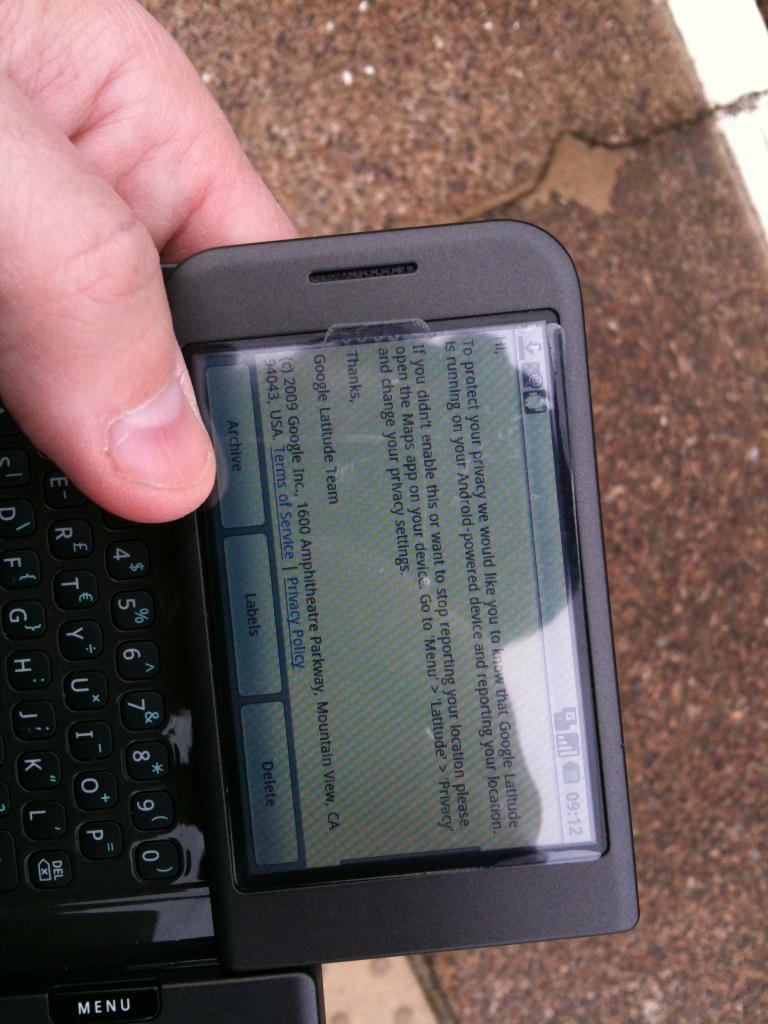<image>
Relay a brief, clear account of the picture shown. A cell phone is instructing its owner how to stop reporting his location via the Maps app. 